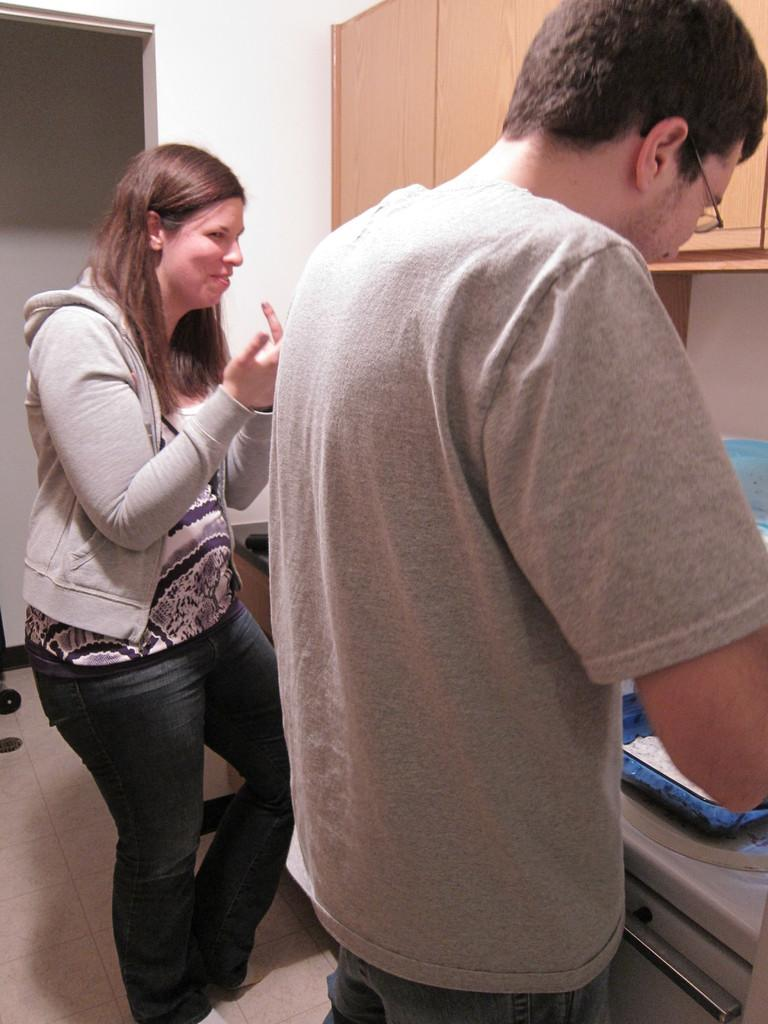How many people are in the image? There are two persons in the image. What is the location of the persons in the image? The persons are in front of a table. What other furniture can be seen in the image? There is a cupboard visible in the image. What part of the room is visible in the image? The wall is visible in the image. What type of income can be seen in the image? There is no income visible in the image; it features two persons in front of a table and a cupboard. What type of game is being played in the image? There is no game being played in the image; it only shows two persons in front of a table and a cupboard. 